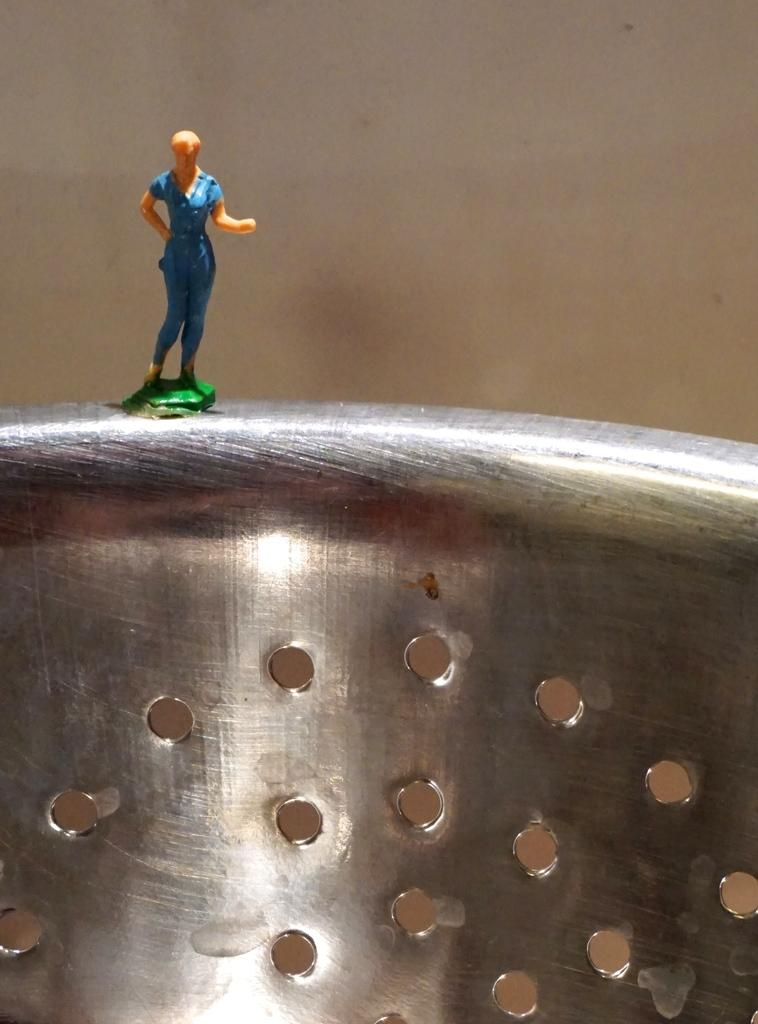What is the main object in the image? There is a toy in the image. Where is the toy located? The toy is on an object. What can be seen in the background of the image? There is a wall in the background of the image. What type of throne is the toy sitting on in the image? There is no throne present in the image; the toy is on an object, but it is not specified as a throne. 